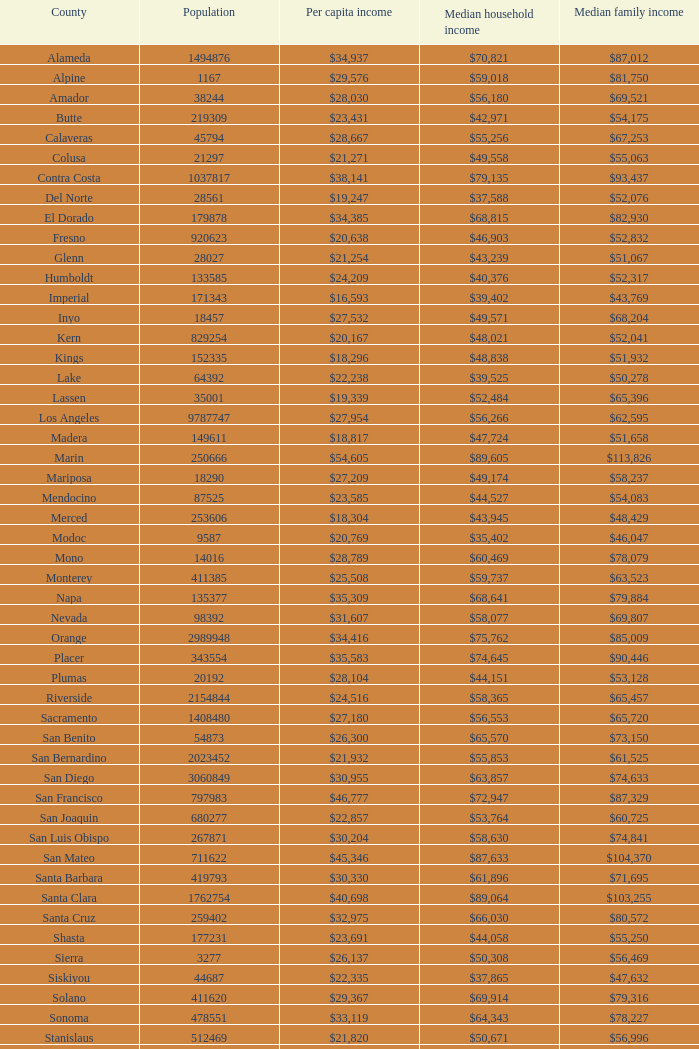Name the median family income for riverside $65,457. 